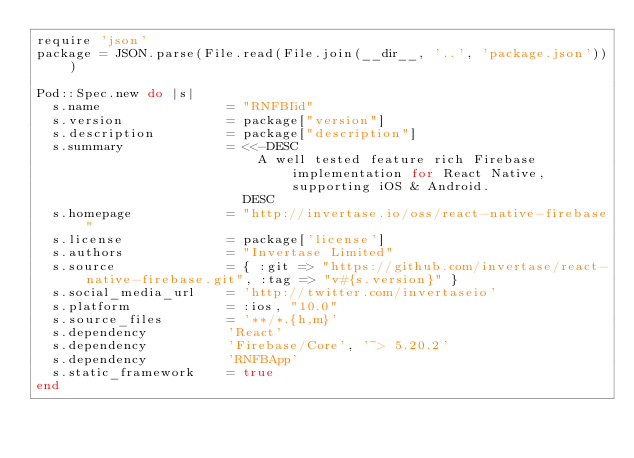<code> <loc_0><loc_0><loc_500><loc_500><_Ruby_>require 'json'
package = JSON.parse(File.read(File.join(__dir__, '..', 'package.json')))

Pod::Spec.new do |s|
  s.name                = "RNFBIid"
  s.version             = package["version"]
  s.description         = package["description"]
  s.summary             = <<-DESC
                            A well tested feature rich Firebase implementation for React Native, supporting iOS & Android.
                          DESC
  s.homepage            = "http://invertase.io/oss/react-native-firebase"
  s.license             = package['license']
  s.authors             = "Invertase Limited"
  s.source              = { :git => "https://github.com/invertase/react-native-firebase.git", :tag => "v#{s.version}" }
  s.social_media_url    = 'http://twitter.com/invertaseio'
  s.platform            = :ios, "10.0"
  s.source_files        = '**/*.{h,m}'
  s.dependency          'React'
  s.dependency          'Firebase/Core', '~> 5.20.2'
  s.dependency          'RNFBApp'
  s.static_framework    = true
end
</code> 